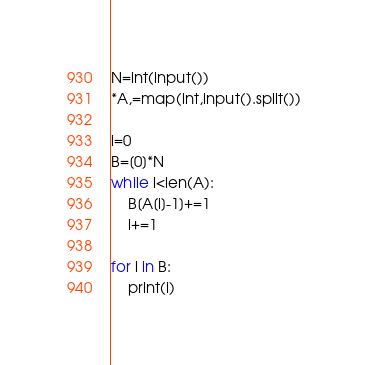Convert code to text. <code><loc_0><loc_0><loc_500><loc_500><_Python_>N=int(input())
*A,=map(int,input().split())

i=0
B=[0]*N
while i<len(A):
    B[A[i]-1]+=1
    i+=1

for i in B:
    print(i)</code> 